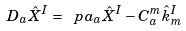<formula> <loc_0><loc_0><loc_500><loc_500>D _ { a } \hat { X } ^ { I } = \ p a _ { a } \hat { X } ^ { I } - C _ { a } ^ { m } \hat { k } _ { m } ^ { I }</formula> 